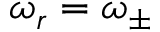<formula> <loc_0><loc_0><loc_500><loc_500>\omega _ { r } = \omega _ { \pm }</formula> 